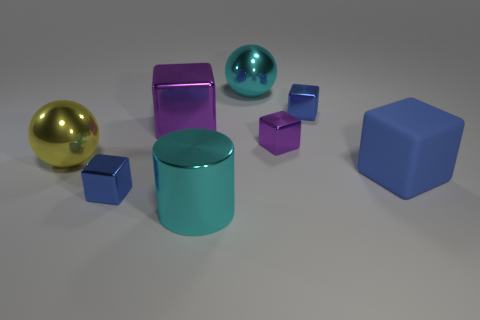Is there anything else that has the same material as the large blue cube?
Your response must be concise. No. There is another purple object that is the same shape as the tiny purple metallic object; what is it made of?
Provide a succinct answer. Metal. There is a sphere that is behind the yellow object; does it have the same size as the large cyan cylinder?
Offer a terse response. Yes. How many shiny objects are either large purple cubes or purple blocks?
Your response must be concise. 2. What is the big thing that is both behind the yellow shiny ball and in front of the big cyan ball made of?
Provide a succinct answer. Metal. Does the big blue cube have the same material as the cylinder?
Your response must be concise. No. What size is the block that is both in front of the large metallic block and to the left of the small purple metal block?
Offer a very short reply. Small. There is a big blue thing; what shape is it?
Offer a very short reply. Cube. What number of things are tiny blue blocks or blue objects that are left of the matte object?
Ensure brevity in your answer.  2. Is the color of the shiny ball that is right of the shiny cylinder the same as the large shiny cylinder?
Your answer should be very brief. Yes. 